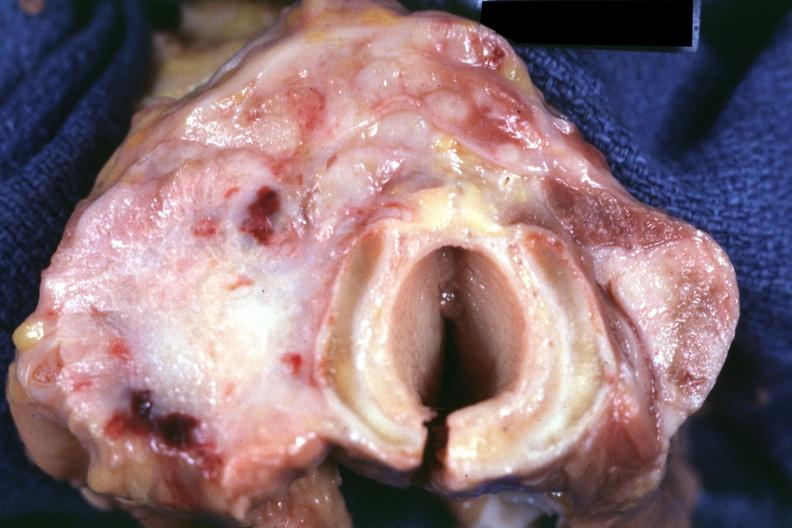what is fibrotic lesion said?
Answer the question using a single word or phrase. To be undifferentiated carcinoma had metastases to lungs 